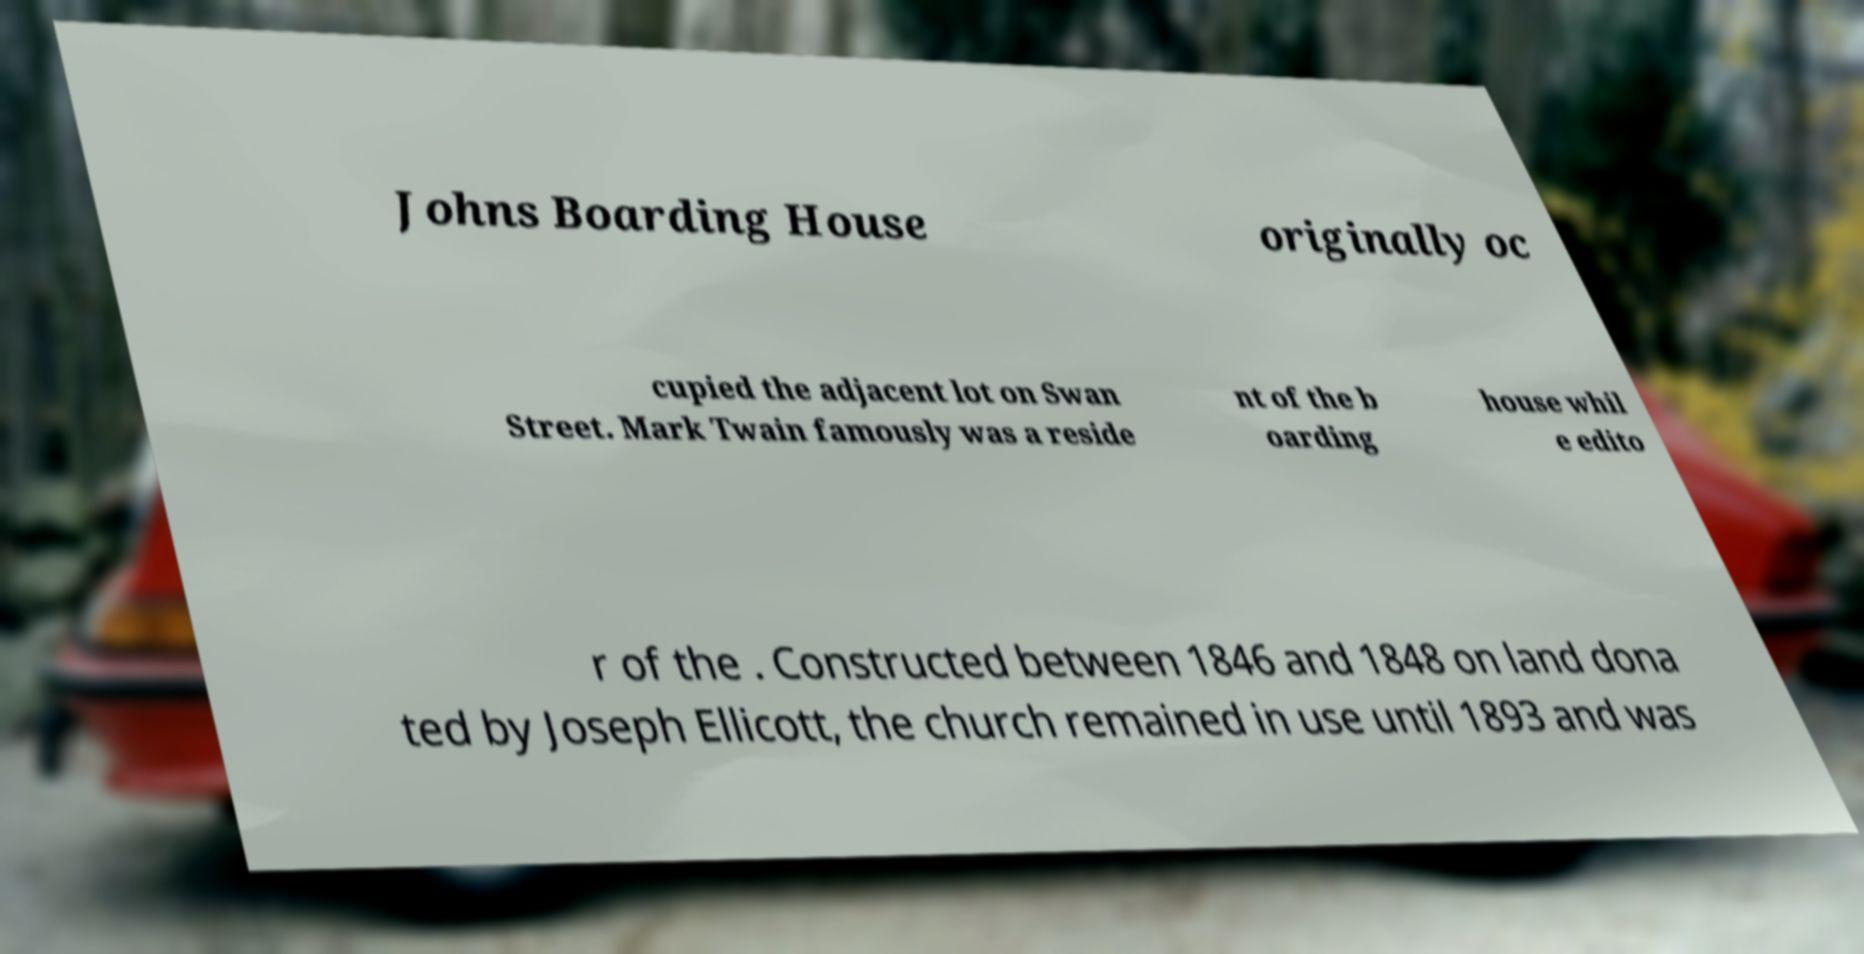What messages or text are displayed in this image? I need them in a readable, typed format. Johns Boarding House originally oc cupied the adjacent lot on Swan Street. Mark Twain famously was a reside nt of the b oarding house whil e edito r of the . Constructed between 1846 and 1848 on land dona ted by Joseph Ellicott, the church remained in use until 1893 and was 